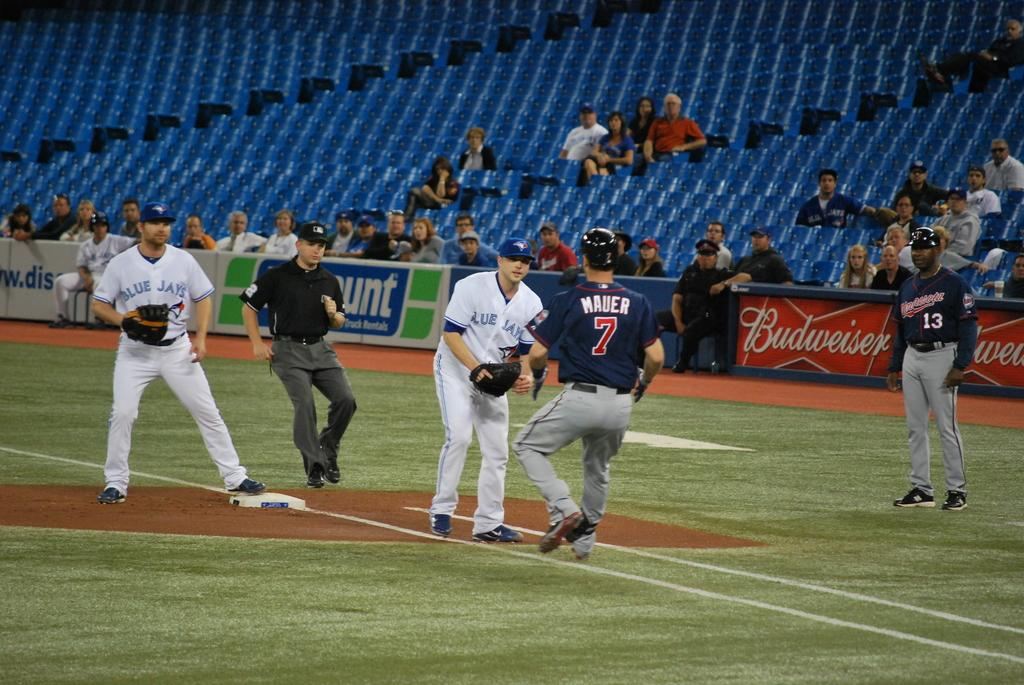<image>
Give a short and clear explanation of the subsequent image. A baseball player with the number 7 on the back of their jersey approaches a player from the other team. 